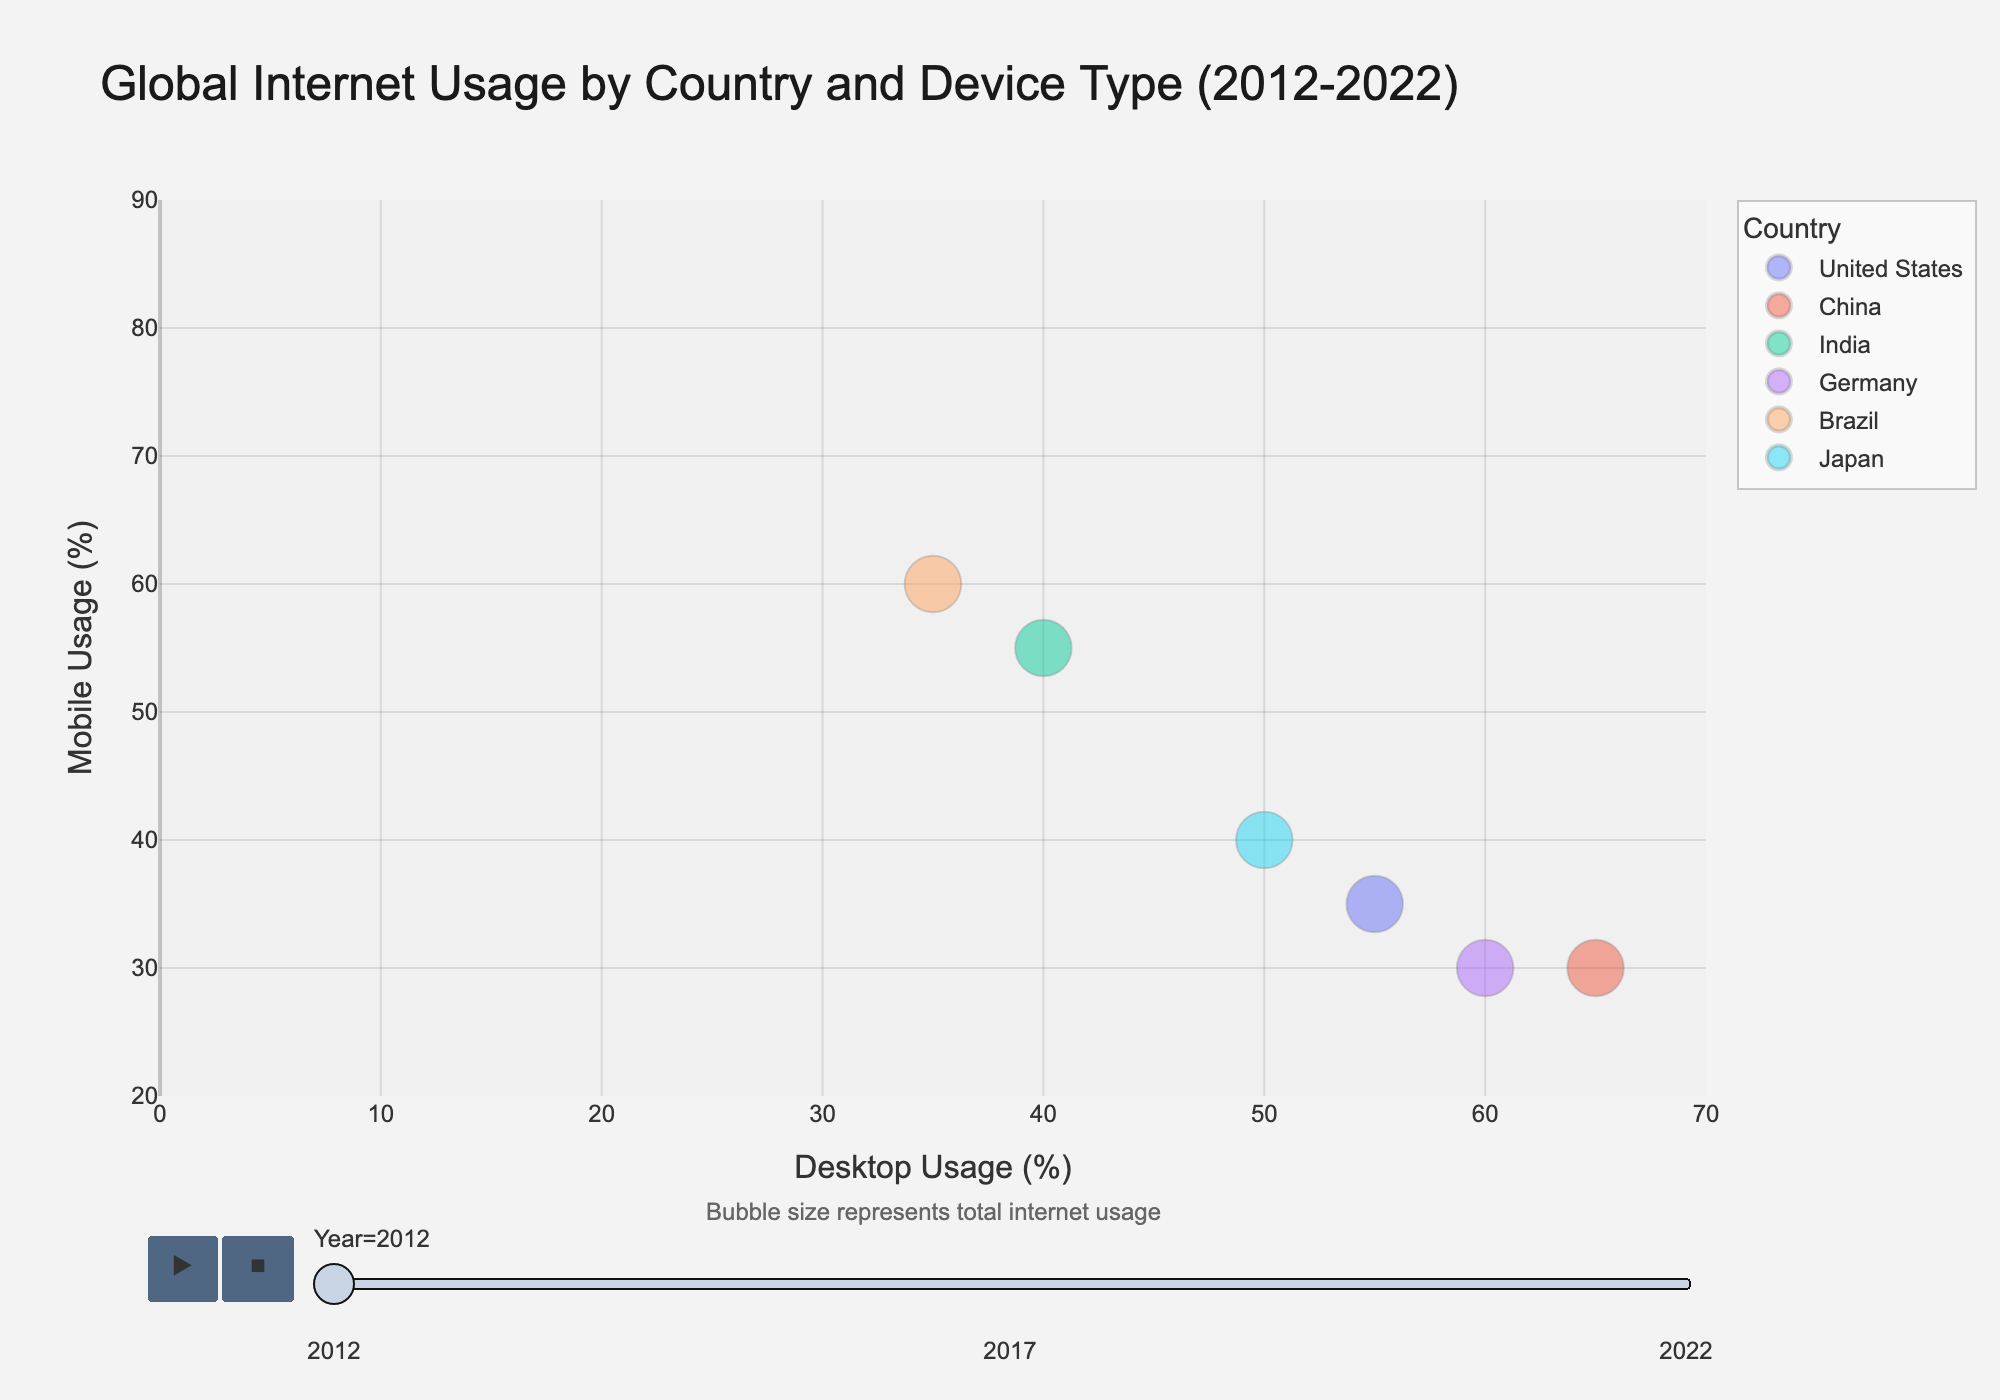What is the title of the figure? The title of the figure is located at the top and it summarizes the content of the figure. By reading it, we find that the title is "Global Internet Usage by Country and Device Type (2012-2022)".
Answer: Global Internet Usage by Country and Device Type (2012-2022) Which country had the highest desktop usage in 2012? By looking at the bubble positions on the x-axis for the year 2012, the furthest bubble to the right represents the highest desktop usage. China had a desktop usage of 65%, which is the highest among all countries in 2012.
Answer: China How did mobile usage in India change from 2012 to 2022? To determine this, we look at the bubbles for India across the years 2012, 2017, and 2022. In 2012, mobile usage was 55%, which increased to 75% in 2017 and further increased to 80% in 2022, indicating a consistent rise.
Answer: Increased from 55% to 80% Compare the trend in desktop usage between the United States and Brazil from 2012 to 2022. To compare the trends, we need to observe the positions of the bubbles for both the United States and Brazil on the x-axis over the years. The United States shows a decrease from 55% in 2012 to 37% in 2017 and further to 25% in 2022. Brazil, on the other hand, decreased from 35% in 2012 to 20% in 2017 and then to 10% in 2022. Both countries show a decreasing trend, but Brazil’s decrease is steeper.
Answer: Both decreased, but Brazil’s decrease is steeper What pattern can be observed regarding the total internet usage size (bubble size) over the years for Japan? The size of the bubbles represents total internet usage. From 2012 to 2022, the bubble size for Japan remains relatively constant, implying that Japan's total internet usage did not change significantly over the decade.
Answer: Relatively constant Which country had a bubble with the largest size in 2017, and what does it imply? Looking at the bubble sizes in 2017, India has the largest bubble. This implies that India had the highest total internet usage among the listed countries in that year.
Answer: India; highest total internet usage Is there any country where the desktop usage remained the same over the decade? By examining the position of the bubbles on the x-axis for each country across the years, we observe that the tablet usage for the United States at 10% remains unchanged over the years, implying constant usage.
Answer: United States In 2022, which countries had equal mobile usage, and what was the usage percentage? For 2022, by finding bubbles with identical y-axis values, we see that both the United States and China had a mobile usage of 65%.
Answer: United States and China; 65% 